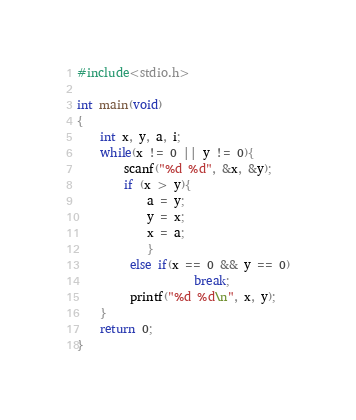<code> <loc_0><loc_0><loc_500><loc_500><_C_>#include<stdio.h>

int main(void)
{
    int x, y, a, i;
    while(x != 0 || y != 0){
        scanf("%d %d", &x, &y);
        if (x > y){
            a = y;
            y = x;
            x = a;
            }
         else if(x == 0 && y == 0)
                    break;
         printf("%d %d\n", x, y);
    }     
    return 0;
}
</code> 